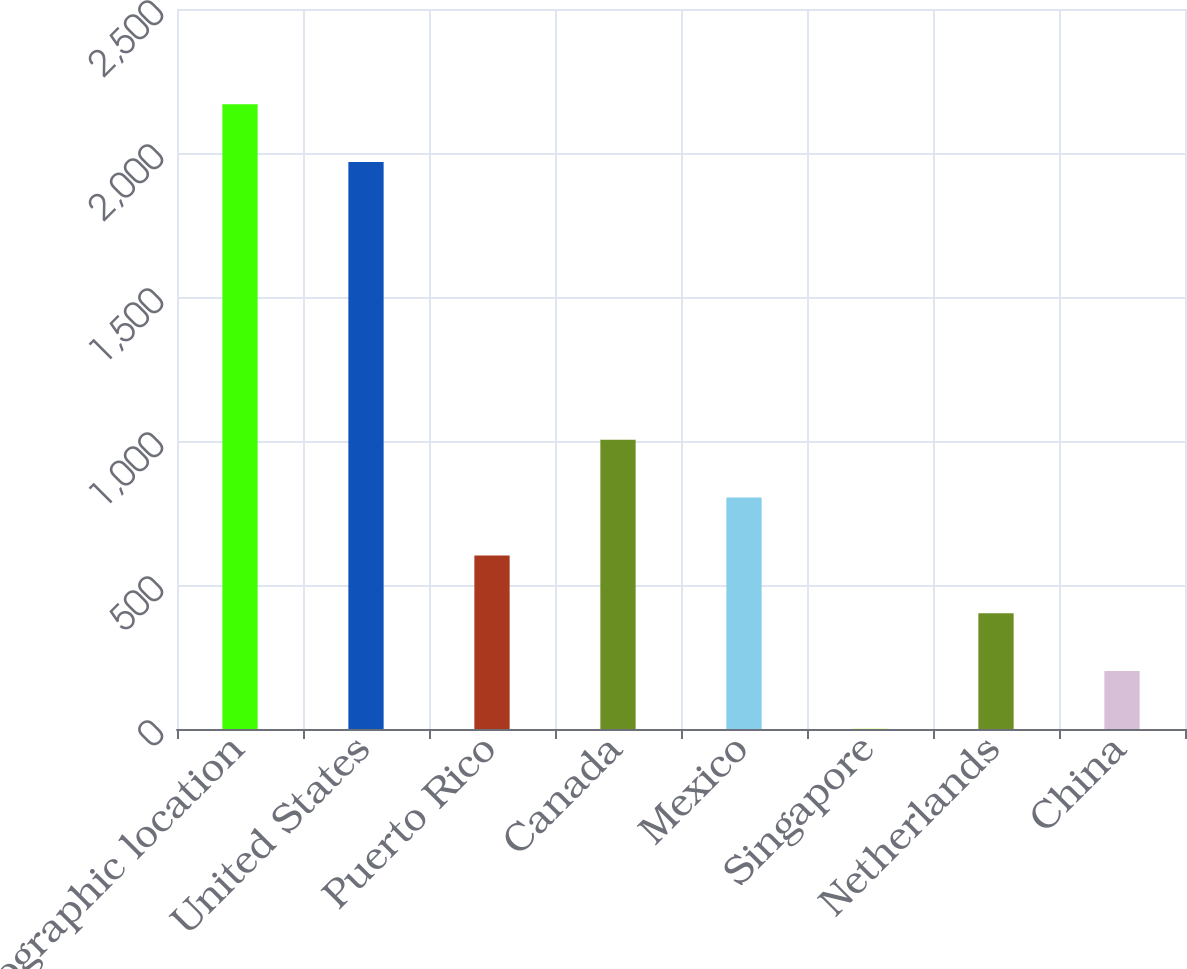<chart> <loc_0><loc_0><loc_500><loc_500><bar_chart><fcel>Geographic location<fcel>United States<fcel>Puerto Rico<fcel>Canada<fcel>Mexico<fcel>Singapore<fcel>Netherlands<fcel>China<nl><fcel>2169.6<fcel>1969<fcel>602.8<fcel>1004<fcel>803.4<fcel>1<fcel>402.2<fcel>201.6<nl></chart> 